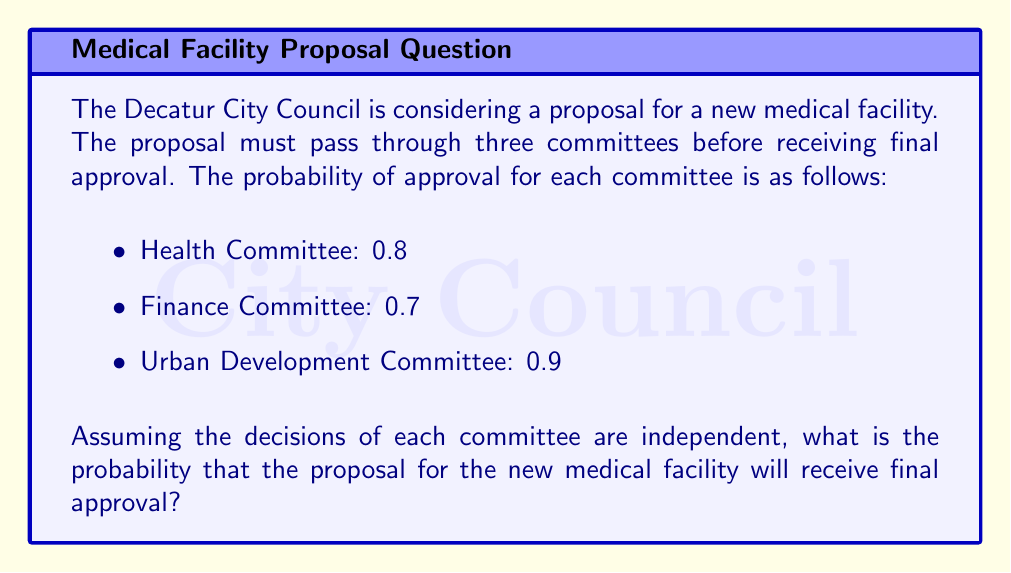Solve this math problem. To solve this problem, we need to follow these steps:

1) For the proposal to receive final approval, it must pass through all three committees successfully.

2) Since the decisions of each committee are independent, we can use the multiplication rule of probability.

3) The probability of all independent events occurring together is the product of their individual probabilities.

4) Let's define the events:
   A: Approval by Health Committee
   B: Approval by Finance Committee
   C: Approval by Urban Development Committee

5) We need to calculate P(A ∩ B ∩ C):

   $$P(A \cap B \cap C) = P(A) \times P(B) \times P(C)$$

6) Substituting the given probabilities:

   $$P(A \cap B \cap C) = 0.8 \times 0.7 \times 0.9$$

7) Calculating:

   $$P(A \cap B \cap C) = 0.504$$

Therefore, the probability that the proposal will receive final approval is 0.504 or 50.4%.
Answer: 0.504 